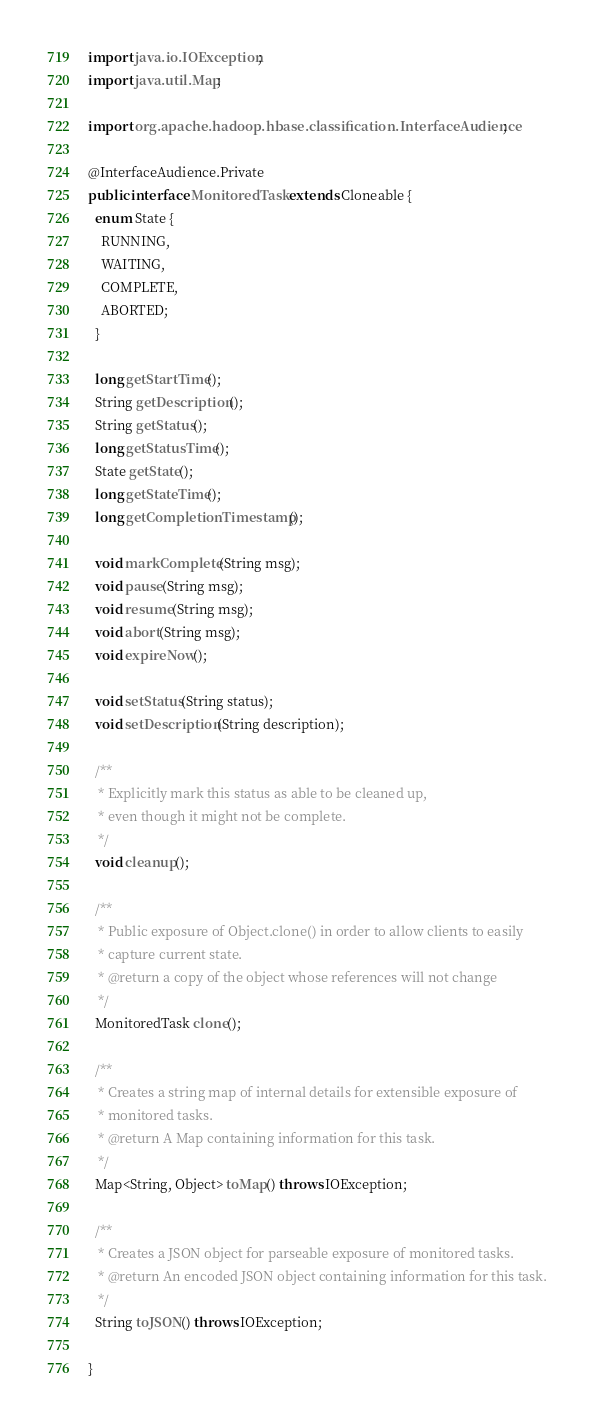<code> <loc_0><loc_0><loc_500><loc_500><_Java_>import java.io.IOException;
import java.util.Map;

import org.apache.hadoop.hbase.classification.InterfaceAudience;

@InterfaceAudience.Private
public interface MonitoredTask extends Cloneable {
  enum State {
    RUNNING,
    WAITING,
    COMPLETE,
    ABORTED;
  }

  long getStartTime();
  String getDescription();
  String getStatus();
  long getStatusTime();
  State getState();
  long getStateTime();
  long getCompletionTimestamp();

  void markComplete(String msg);
  void pause(String msg);
  void resume(String msg);
  void abort(String msg);
  void expireNow();

  void setStatus(String status);
  void setDescription(String description);

  /**
   * Explicitly mark this status as able to be cleaned up,
   * even though it might not be complete.
   */
  void cleanup();

  /**
   * Public exposure of Object.clone() in order to allow clients to easily 
   * capture current state.
   * @return a copy of the object whose references will not change
   */
  MonitoredTask clone();

  /**
   * Creates a string map of internal details for extensible exposure of 
   * monitored tasks.
   * @return A Map containing information for this task.
   */
  Map<String, Object> toMap() throws IOException;

  /**
   * Creates a JSON object for parseable exposure of monitored tasks.
   * @return An encoded JSON object containing information for this task.
   */
  String toJSON() throws IOException;

}
</code> 